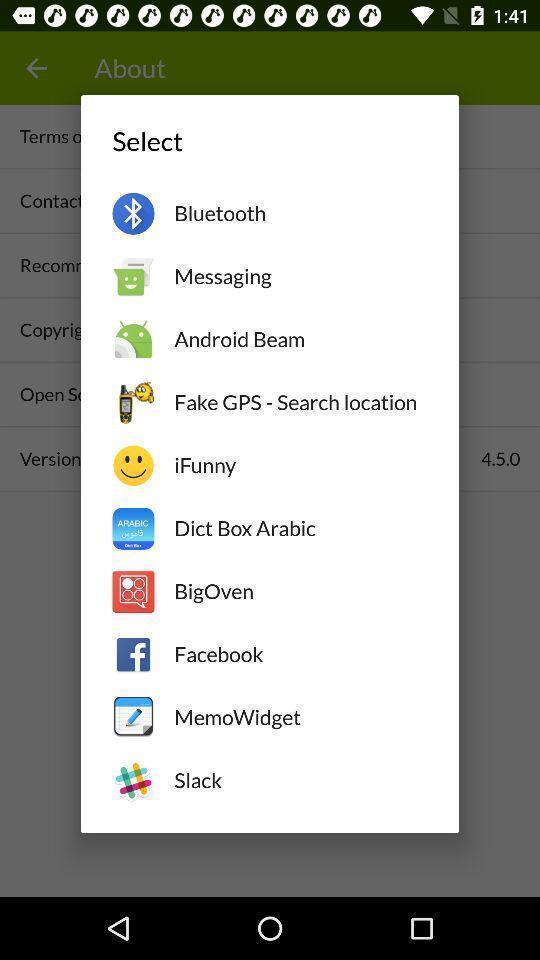Describe the content in this image. Pop up to select a social app. 